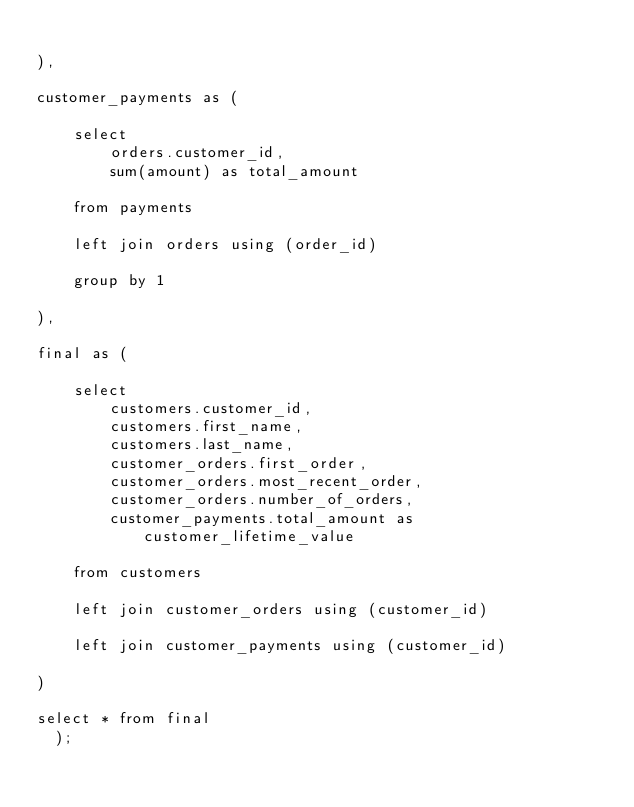<code> <loc_0><loc_0><loc_500><loc_500><_SQL_>
),

customer_payments as (

    select
        orders.customer_id,
        sum(amount) as total_amount

    from payments

    left join orders using (order_id)

    group by 1

),

final as (

    select
        customers.customer_id,
        customers.first_name,
        customers.last_name,
        customer_orders.first_order,
        customer_orders.most_recent_order,
        customer_orders.number_of_orders,
        customer_payments.total_amount as customer_lifetime_value

    from customers

    left join customer_orders using (customer_id)

    left join customer_payments using (customer_id)

)

select * from final
  );</code> 